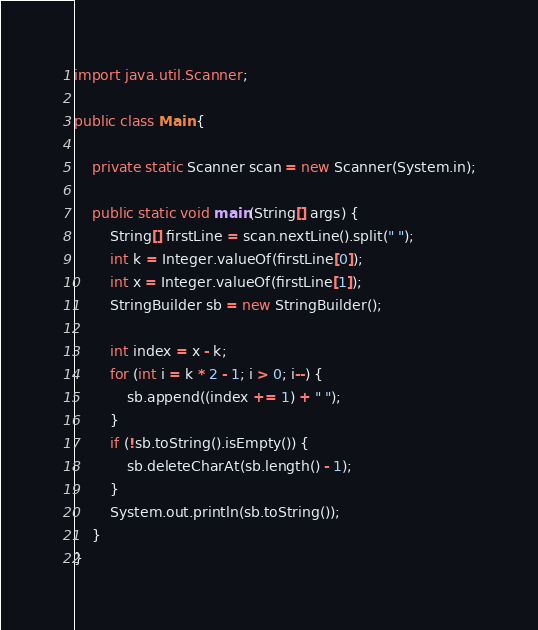<code> <loc_0><loc_0><loc_500><loc_500><_Java_>import java.util.Scanner;

public class Main {

	private static Scanner scan = new Scanner(System.in);

	public static void main(String[] args) {
		String[] firstLine = scan.nextLine().split(" ");
		int k = Integer.valueOf(firstLine[0]);
		int x = Integer.valueOf(firstLine[1]);
		StringBuilder sb = new StringBuilder();

		int index = x - k;
		for (int i = k * 2 - 1; i > 0; i--) {
			sb.append((index += 1) + " ");
		}
		if (!sb.toString().isEmpty()) {
			sb.deleteCharAt(sb.length() - 1);
		}
		System.out.println(sb.toString());
	}
}
</code> 